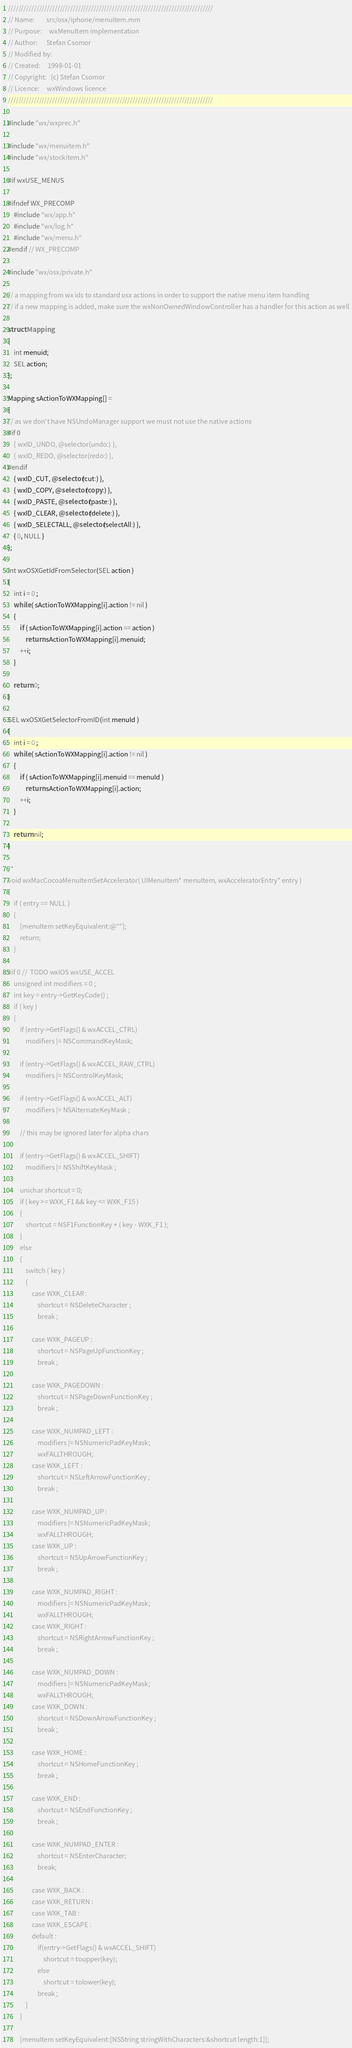Convert code to text. <code><loc_0><loc_0><loc_500><loc_500><_ObjectiveC_>///////////////////////////////////////////////////////////////////////////////
// Name:        src/osx/iphone/menuitem.mm
// Purpose:     wxMenuItem implementation
// Author:      Stefan Csomor
// Modified by:
// Created:     1998-01-01
// Copyright:   (c) Stefan Csomor
// Licence:     wxWindows licence
///////////////////////////////////////////////////////////////////////////////

#include "wx/wxprec.h"

#include "wx/menuitem.h"
#include "wx/stockitem.h"

#if wxUSE_MENUS

#ifndef WX_PRECOMP
    #include "wx/app.h"
    #include "wx/log.h"
    #include "wx/menu.h"
#endif // WX_PRECOMP

#include "wx/osx/private.h"

// a mapping from wx ids to standard osx actions in order to support the native menu item handling
// if a new mapping is added, make sure the wxNonOwnedWindowController has a handler for this action as well

struct Mapping
{
    int menuid;
    SEL action;
};

Mapping sActionToWXMapping[] =
{
// as we don't have NSUndoManager support we must not use the native actions
#if 0
    { wxID_UNDO, @selector(undo:) },
    { wxID_REDO, @selector(redo:) },
#endif
    { wxID_CUT, @selector(cut:) },
    { wxID_COPY, @selector(copy:) },
    { wxID_PASTE, @selector(paste:) },
    { wxID_CLEAR, @selector(delete:) },
    { wxID_SELECTALL, @selector(selectAll:) },
    { 0, NULL }
};

int wxOSXGetIdFromSelector(SEL action )
{
    int i = 0 ;
    while ( sActionToWXMapping[i].action != nil )
    {
        if ( sActionToWXMapping[i].action == action )
            return sActionToWXMapping[i].menuid;
        ++i;
    }

    return 0;
}

SEL wxOSXGetSelectorFromID(int menuId )
{
    int i = 0 ;
    while ( sActionToWXMapping[i].action != nil )
    {
        if ( sActionToWXMapping[i].menuid == menuId )
            return sActionToWXMapping[i].action;
        ++i;
    }

    return nil;
}

/*
void wxMacCocoaMenuItemSetAccelerator( UIMenuItem* menuItem, wxAcceleratorEntry* entry )
{
    if ( entry == NULL )
    {
        [menuItem setKeyEquivalent:@""];
        return;
    }

#if 0 //  TODO wxIOS wxUSE_ACCEL
    unsigned int modifiers = 0 ;
    int key = entry->GetKeyCode() ;
    if ( key )
    {
        if (entry->GetFlags() & wxACCEL_CTRL)
            modifiers |= NSCommandKeyMask;

        if (entry->GetFlags() & wxACCEL_RAW_CTRL)
            modifiers |= NSControlKeyMask;

        if (entry->GetFlags() & wxACCEL_ALT)
            modifiers |= NSAlternateKeyMask ;

        // this may be ignored later for alpha chars

        if (entry->GetFlags() & wxACCEL_SHIFT)
            modifiers |= NSShiftKeyMask ;

        unichar shortcut = 0;
        if ( key >= WXK_F1 && key <= WXK_F15 )
        {
            shortcut = NSF1FunctionKey + ( key - WXK_F1 );
        }
        else
        {
            switch ( key )
            {
                case WXK_CLEAR :
                    shortcut = NSDeleteCharacter ;
                    break ;

                case WXK_PAGEUP :
                    shortcut = NSPageUpFunctionKey ;
                    break ;

                case WXK_PAGEDOWN :
                    shortcut = NSPageDownFunctionKey ;
                    break ;

                case WXK_NUMPAD_LEFT :
                    modifiers |= NSNumericPadKeyMask;
                    wxFALLTHROUGH;
                case WXK_LEFT :
                    shortcut = NSLeftArrowFunctionKey ;
                    break ;

                case WXK_NUMPAD_UP :
                    modifiers |= NSNumericPadKeyMask;
                    wxFALLTHROUGH;
                case WXK_UP :
                    shortcut = NSUpArrowFunctionKey ;
                    break ;

                case WXK_NUMPAD_RIGHT :
                    modifiers |= NSNumericPadKeyMask;
                    wxFALLTHROUGH;
                case WXK_RIGHT :
                    shortcut = NSRightArrowFunctionKey ;
                    break ;

                case WXK_NUMPAD_DOWN :
                    modifiers |= NSNumericPadKeyMask;
                    wxFALLTHROUGH;
                case WXK_DOWN :
                    shortcut = NSDownArrowFunctionKey ;
                    break ;

                case WXK_HOME :
                    shortcut = NSHomeFunctionKey ;
                    break ;

                case WXK_END :
                    shortcut = NSEndFunctionKey ;
                    break ;

                case WXK_NUMPAD_ENTER :
                    shortcut = NSEnterCharacter;
                    break;

                case WXK_BACK :
                case WXK_RETURN :
                case WXK_TAB :
                case WXK_ESCAPE :
                default :
                    if(entry->GetFlags() & wxACCEL_SHIFT)
                        shortcut = toupper(key);
                    else
                        shortcut = tolower(key);
                    break ;
            }
        }

        [menuItem setKeyEquivalent:[NSString stringWithCharacters:&shortcut length:1]];</code> 